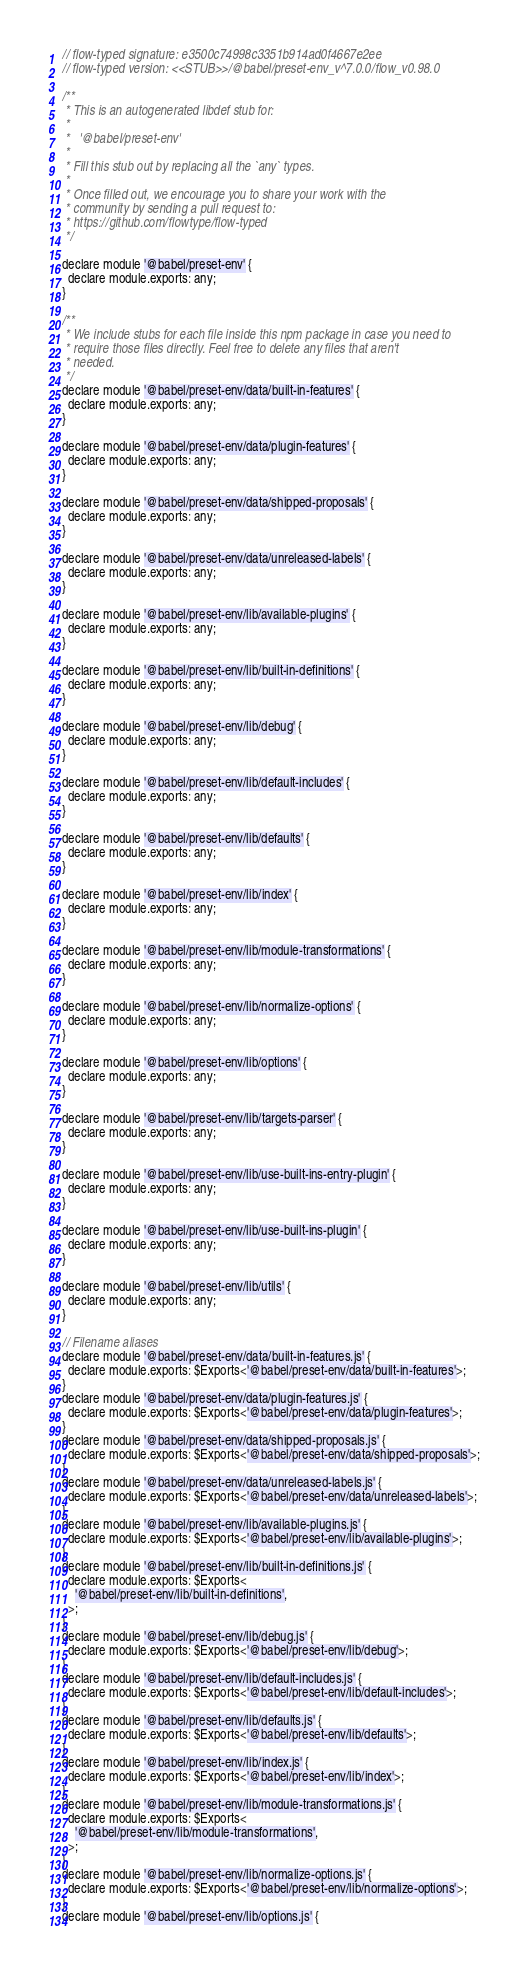<code> <loc_0><loc_0><loc_500><loc_500><_JavaScript_>// flow-typed signature: e3500c74998c3351b914ad0f4667e2ee
// flow-typed version: <<STUB>>/@babel/preset-env_v^7.0.0/flow_v0.98.0

/**
 * This is an autogenerated libdef stub for:
 *
 *   '@babel/preset-env'
 *
 * Fill this stub out by replacing all the `any` types.
 *
 * Once filled out, we encourage you to share your work with the
 * community by sending a pull request to:
 * https://github.com/flowtype/flow-typed
 */

declare module '@babel/preset-env' {
  declare module.exports: any;
}

/**
 * We include stubs for each file inside this npm package in case you need to
 * require those files directly. Feel free to delete any files that aren't
 * needed.
 */
declare module '@babel/preset-env/data/built-in-features' {
  declare module.exports: any;
}

declare module '@babel/preset-env/data/plugin-features' {
  declare module.exports: any;
}

declare module '@babel/preset-env/data/shipped-proposals' {
  declare module.exports: any;
}

declare module '@babel/preset-env/data/unreleased-labels' {
  declare module.exports: any;
}

declare module '@babel/preset-env/lib/available-plugins' {
  declare module.exports: any;
}

declare module '@babel/preset-env/lib/built-in-definitions' {
  declare module.exports: any;
}

declare module '@babel/preset-env/lib/debug' {
  declare module.exports: any;
}

declare module '@babel/preset-env/lib/default-includes' {
  declare module.exports: any;
}

declare module '@babel/preset-env/lib/defaults' {
  declare module.exports: any;
}

declare module '@babel/preset-env/lib/index' {
  declare module.exports: any;
}

declare module '@babel/preset-env/lib/module-transformations' {
  declare module.exports: any;
}

declare module '@babel/preset-env/lib/normalize-options' {
  declare module.exports: any;
}

declare module '@babel/preset-env/lib/options' {
  declare module.exports: any;
}

declare module '@babel/preset-env/lib/targets-parser' {
  declare module.exports: any;
}

declare module '@babel/preset-env/lib/use-built-ins-entry-plugin' {
  declare module.exports: any;
}

declare module '@babel/preset-env/lib/use-built-ins-plugin' {
  declare module.exports: any;
}

declare module '@babel/preset-env/lib/utils' {
  declare module.exports: any;
}

// Filename aliases
declare module '@babel/preset-env/data/built-in-features.js' {
  declare module.exports: $Exports<'@babel/preset-env/data/built-in-features'>;
}
declare module '@babel/preset-env/data/plugin-features.js' {
  declare module.exports: $Exports<'@babel/preset-env/data/plugin-features'>;
}
declare module '@babel/preset-env/data/shipped-proposals.js' {
  declare module.exports: $Exports<'@babel/preset-env/data/shipped-proposals'>;
}
declare module '@babel/preset-env/data/unreleased-labels.js' {
  declare module.exports: $Exports<'@babel/preset-env/data/unreleased-labels'>;
}
declare module '@babel/preset-env/lib/available-plugins.js' {
  declare module.exports: $Exports<'@babel/preset-env/lib/available-plugins'>;
}
declare module '@babel/preset-env/lib/built-in-definitions.js' {
  declare module.exports: $Exports<
    '@babel/preset-env/lib/built-in-definitions',
  >;
}
declare module '@babel/preset-env/lib/debug.js' {
  declare module.exports: $Exports<'@babel/preset-env/lib/debug'>;
}
declare module '@babel/preset-env/lib/default-includes.js' {
  declare module.exports: $Exports<'@babel/preset-env/lib/default-includes'>;
}
declare module '@babel/preset-env/lib/defaults.js' {
  declare module.exports: $Exports<'@babel/preset-env/lib/defaults'>;
}
declare module '@babel/preset-env/lib/index.js' {
  declare module.exports: $Exports<'@babel/preset-env/lib/index'>;
}
declare module '@babel/preset-env/lib/module-transformations.js' {
  declare module.exports: $Exports<
    '@babel/preset-env/lib/module-transformations',
  >;
}
declare module '@babel/preset-env/lib/normalize-options.js' {
  declare module.exports: $Exports<'@babel/preset-env/lib/normalize-options'>;
}
declare module '@babel/preset-env/lib/options.js' {</code> 